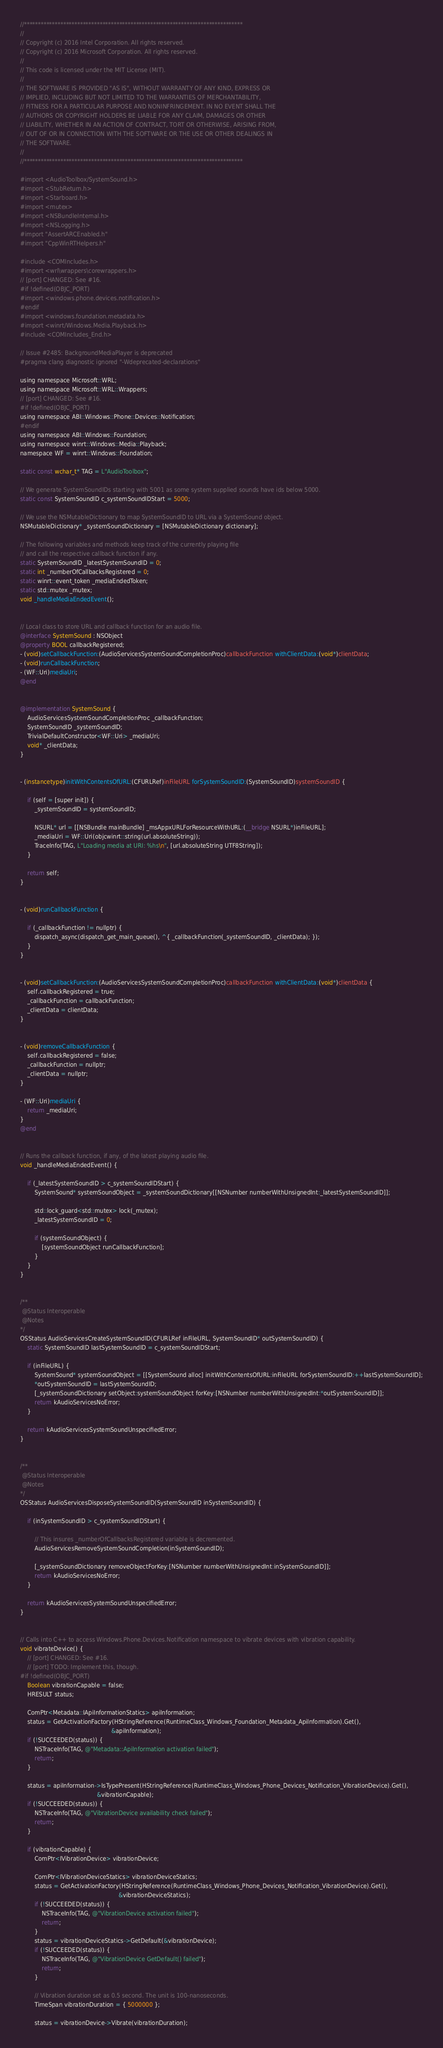<code> <loc_0><loc_0><loc_500><loc_500><_ObjectiveC_>//******************************************************************************
//
// Copyright (c) 2016 Intel Corporation. All rights reserved.
// Copyright (c) 2016 Microsoft Corporation. All rights reserved.
//
// This code is licensed under the MIT License (MIT).
//
// THE SOFTWARE IS PROVIDED "AS IS", WITHOUT WARRANTY OF ANY KIND, EXPRESS OR
// IMPLIED, INCLUDING BUT NOT LIMITED TO THE WARRANTIES OF MERCHANTABILITY,
// FITNESS FOR A PARTICULAR PURPOSE AND NONINFRINGEMENT. IN NO EVENT SHALL THE
// AUTHORS OR COPYRIGHT HOLDERS BE LIABLE FOR ANY CLAIM, DAMAGES OR OTHER
// LIABILITY, WHETHER IN AN ACTION OF CONTRACT, TORT OR OTHERWISE, ARISING FROM,
// OUT OF OR IN CONNECTION WITH THE SOFTWARE OR THE USE OR OTHER DEALINGS IN
// THE SOFTWARE.
//
//******************************************************************************

#import <AudioToolbox/SystemSound.h>
#import <StubReturn.h>
#import <Starboard.h>
#import <mutex>
#import <NSBundleInternal.h>
#import <NSLogging.h>
#import "AssertARCEnabled.h"
#import "CppWinRTHelpers.h"

#include <COMIncludes.h>
#import <wrl\wrappers\corewrappers.h>
// [port] CHANGED: See #16.
#if !defined(OBJC_PORT)
#import <windows.phone.devices.notification.h>
#endif
#import <windows.foundation.metadata.h>
#import <winrt/Windows.Media.Playback.h>
#include <COMIncludes_End.h>

// Issue #2485: BackgroundMediaPlayer is deprecated
#pragma clang diagnostic ignored "-Wdeprecated-declarations"

using namespace Microsoft::WRL;
using namespace Microsoft::WRL::Wrappers;
// [port] CHANGED: See #16.
#if !defined(OBJC_PORT)
using namespace ABI::Windows::Phone::Devices::Notification;
#endif
using namespace ABI::Windows::Foundation;
using namespace winrt::Windows::Media::Playback;
namespace WF = winrt::Windows::Foundation;

static const wchar_t* TAG = L"AudioToolbox";

// We generate SystemSoundIDs starting with 5001 as some system supplied sounds have ids below 5000.
static const SystemSoundID c_systemSoundIDStart = 5000;

// We use the NSMutableDictionary to map SystemSoundID to URL via a SystemSound object.
NSMutableDictionary* _systemSoundDictionary = [NSMutableDictionary dictionary];

// The following variables and methods keep track of the currently playing file
// and call the respective callback function if any.
static SystemSoundID _latestSystemSoundID = 0;
static int _numberOfCallbacksRegistered = 0;
static winrt::event_token _mediaEndedToken;
static std::mutex _mutex;
void _handleMediaEndedEvent();


// Local class to store URL and callback function for an audio file.
@interface SystemSound : NSObject
@property BOOL callbackRegistered;
- (void)setCallbackFunction:(AudioServicesSystemSoundCompletionProc)callbackFunction withClientData:(void*)clientData;
- (void)runCallbackFunction;
- (WF::Uri)mediaUri;
@end


@implementation SystemSound {
    AudioServicesSystemSoundCompletionProc _callbackFunction;
    SystemSoundID _systemSoundID;
    TrivialDefaultConstructor<WF::Uri> _mediaUri;
    void* _clientData;
}


- (instancetype)initWithContentsOfURL:(CFURLRef)inFileURL forSystemSoundID:(SystemSoundID)systemSoundID {

    if (self = [super init]) {
        _systemSoundID = systemSoundID;

        NSURL* url = [[NSBundle mainBundle] _msAppxURLForResourceWithURL:(__bridge NSURL*)inFileURL];
        _mediaUri = WF::Uri(objcwinrt::string(url.absoluteString));
        TraceInfo(TAG, L"Loading media at URI: %hs\n", [url.absoluteString UTF8String]);
    }

    return self;
}


- (void)runCallbackFunction {

    if (_callbackFunction != nullptr) {
        dispatch_async(dispatch_get_main_queue(), ^{ _callbackFunction(_systemSoundID, _clientData); });
    }
}


- (void)setCallbackFunction:(AudioServicesSystemSoundCompletionProc)callbackFunction withClientData:(void*)clientData {
    self.callbackRegistered = true;
    _callbackFunction = callbackFunction;
    _clientData = clientData;
}


- (void)removeCallbackFunction {
    self.callbackRegistered = false;
    _callbackFunction = nullptr;
    _clientData = nullptr;
}

- (WF::Uri)mediaUri {
    return _mediaUri;
}
@end


// Runs the callback function, if any, of the latest playing audio file.
void _handleMediaEndedEvent() {

    if (_latestSystemSoundID > c_systemSoundIDStart) {
        SystemSound* systemSoundObject = _systemSoundDictionary[[NSNumber numberWithUnsignedInt:_latestSystemSoundID]];

        std::lock_guard<std::mutex> lock(_mutex);
        _latestSystemSoundID = 0;

        if (systemSoundObject) {
            [systemSoundObject runCallbackFunction];
        }
    }
}


/**
 @Status Interoperable
 @Notes
*/
OSStatus AudioServicesCreateSystemSoundID(CFURLRef inFileURL, SystemSoundID* outSystemSoundID) {
    static SystemSoundID lastSystemSoundID = c_systemSoundIDStart;

    if (inFileURL) {
        SystemSound* systemSoundObject = [[SystemSound alloc] initWithContentsOfURL:inFileURL forSystemSoundID:++lastSystemSoundID];
        *outSystemSoundID = lastSystemSoundID;
        [_systemSoundDictionary setObject:systemSoundObject forKey:[NSNumber numberWithUnsignedInt:*outSystemSoundID]];
        return kAudioServicesNoError;
    }

    return kAudioServicesSystemSoundUnspecifiedError;
}


/**
 @Status Interoperable
 @Notes
*/
OSStatus AudioServicesDisposeSystemSoundID(SystemSoundID inSystemSoundID) {

    if (inSystemSoundID > c_systemSoundIDStart) {

        // This insures _numberOfCallbacksRegistered variable is decremented.
        AudioServicesRemoveSystemSoundCompletion(inSystemSoundID);

        [_systemSoundDictionary removeObjectForKey:[NSNumber numberWithUnsignedInt:inSystemSoundID]];
        return kAudioServicesNoError;
    }

    return kAudioServicesSystemSoundUnspecifiedError;
}


// Calls into C++ to access Windows.Phone.Devices.Notification namespace to vibrate devices with vibration capability.
void vibrateDevice() {
    // [port] CHANGED: See #16.
    // [port] TODO: Implement this, though.
#if !defined(OBJC_PORT)
    Boolean vibrationCapable = false;
    HRESULT status;

    ComPtr<Metadata::IApiInformationStatics> apiInformation;
    status = GetActivationFactory(HStringReference(RuntimeClass_Windows_Foundation_Metadata_ApiInformation).Get(),
                                                   &apiInformation);
    if (!SUCCEEDED(status)) {
        NSTraceInfo(TAG, @"Metadata::ApiInformation activation failed");
        return;
    }

    status = apiInformation->IsTypePresent(HStringReference(RuntimeClass_Windows_Phone_Devices_Notification_VibrationDevice).Get(),
                                           &vibrationCapable);
    if (!SUCCEEDED(status)) {
        NSTraceInfo(TAG, @"VibrationDevice availability check failed");
        return;
    }

    if (vibrationCapable) {
        ComPtr<IVibrationDevice> vibrationDevice;

        ComPtr<IVibrationDeviceStatics> vibrationDeviceStatics;
        status = GetActivationFactory(HStringReference(RuntimeClass_Windows_Phone_Devices_Notification_VibrationDevice).Get(),
                                                       &vibrationDeviceStatics);
        if (!SUCCEEDED(status)) {
            NSTraceInfo(TAG, @"VibrationDevice activation failed");
            return;
        }
        status = vibrationDeviceStatics->GetDefault(&vibrationDevice);
        if (!SUCCEEDED(status)) {
            NSTraceInfo(TAG, @"VibrationDevice GetDefault() failed");
            return;
        }

        // Vibration duration set as 0.5 second. The unit is 100-nanoseconds.
        TimeSpan vibrationDuration = { 5000000 };

        status = vibrationDevice->Vibrate(vibrationDuration);</code> 